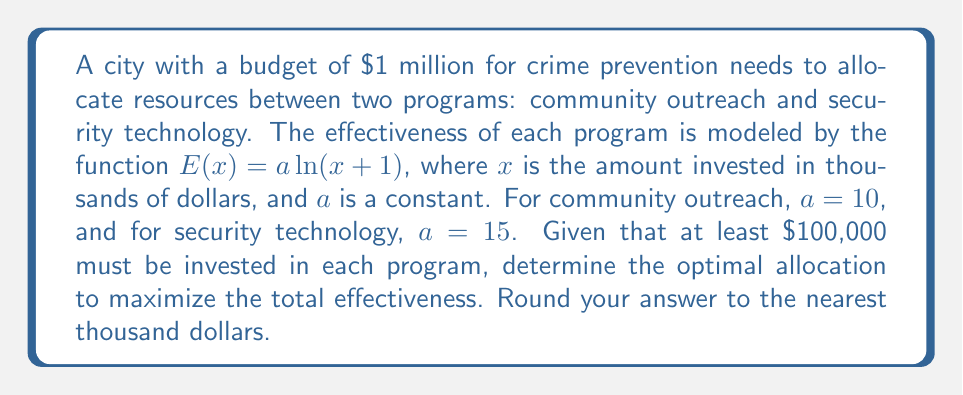Provide a solution to this math problem. 1) Let $x$ be the amount invested in community outreach and $y$ be the amount invested in security technology (both in thousands of dollars).

2) The total effectiveness is given by:
   $$E_{total} = 10\ln(x+1) + 15\ln(y+1)$$

3) The constraints are:
   $$x + y = 1000$$ (total budget)
   $$x \geq 100, y \geq 100$$ (minimum investment)

4) To maximize $E_{total}$, we use the method of Lagrange multipliers:
   $$L(x,y,\lambda) = 10\ln(x+1) + 15\ln(y+1) + \lambda(1000-x-y)$$

5) Taking partial derivatives and setting them to zero:
   $$\frac{\partial L}{\partial x} = \frac{10}{x+1} - \lambda = 0$$
   $$\frac{\partial L}{\partial y} = \frac{15}{y+1} - \lambda = 0$$
   $$\frac{\partial L}{\partial \lambda} = 1000 - x - y = 0$$

6) From the first two equations:
   $$\frac{10}{x+1} = \frac{15}{y+1}$$

7) Cross-multiplying:
   $$10(y+1) = 15(x+1)$$
   $$10y + 10 = 15x + 15$$
   $$10y = 15x + 5$$
   $$y = \frac{3x + 1}{2}$$

8) Substituting into the budget constraint:
   $$x + \frac{3x + 1}{2} = 1000$$
   $$2x + 3x + 1 = 2000$$
   $$5x = 1999$$
   $$x = 399.8$$

9) Solving for y:
   $$y = 1000 - 399.8 = 600.2$$

10) Rounding to the nearest thousand:
    $x = 400$ thousand dollars (community outreach)
    $y = 600$ thousand dollars (security technology)
Answer: $400,000 for community outreach, $600,000 for security technology 